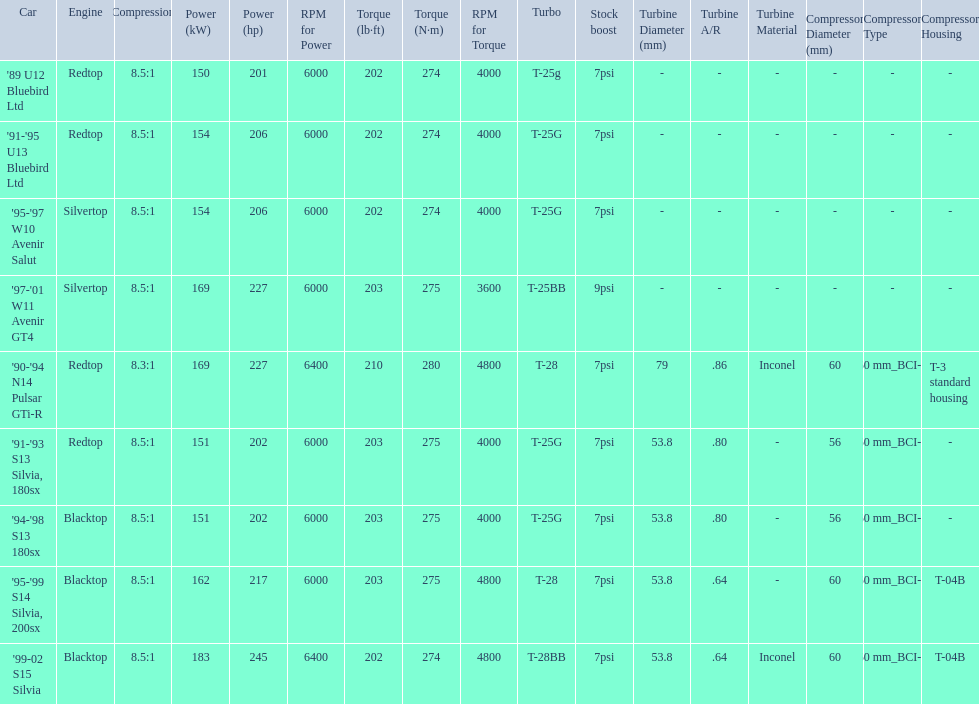Which cars list turbine details? '90-'94 N14 Pulsar GTi-R, '91-'93 S13 Silvia, 180sx, '94-'98 S13 180sx, '95-'99 S14 Silvia, 200sx, '99-02 S15 Silvia. Which of these hit their peak hp at the highest rpm? '90-'94 N14 Pulsar GTi-R, '99-02 S15 Silvia. Of those what is the compression of the only engine that isn't blacktop?? 8.3:1. 